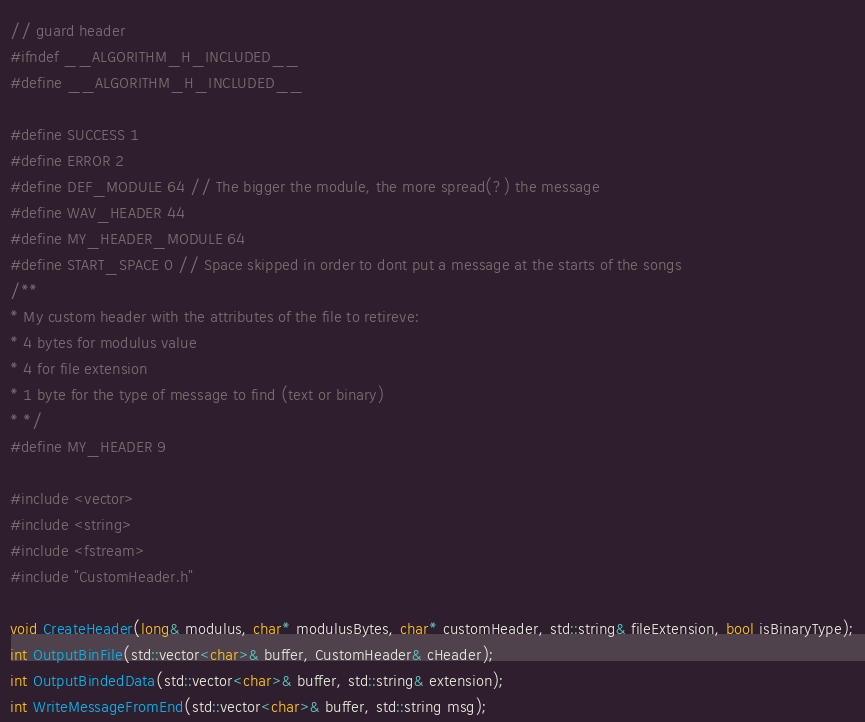<code> <loc_0><loc_0><loc_500><loc_500><_C_>// guard header
#ifndef __ALGORITHM_H_INCLUDED__
#define __ALGORITHM_H_INCLUDED__

#define SUCCESS 1
#define ERROR 2
#define DEF_MODULE 64 // The bigger the module, the more spread(?) the message
#define WAV_HEADER 44
#define MY_HEADER_MODULE 64
#define START_SPACE 0 // Space skipped in order to dont put a message at the starts of the songs
/**
* My custom header with the attributes of the file to retireve:
* 4 bytes for modulus value
* 4 for file extension
* 1 byte for the type of message to find (text or binary)
* */
#define MY_HEADER 9

#include <vector>
#include <string>
#include <fstream>
#include "CustomHeader.h"

void CreateHeader(long& modulus, char* modulusBytes, char* customHeader, std::string& fileExtension, bool isBinaryType);
int OutputBinFile(std::vector<char>& buffer, CustomHeader& cHeader);
int OutputBindedData(std::vector<char>& buffer, std::string& extension);
int WriteMessageFromEnd(std::vector<char>& buffer, std::string msg);</code> 